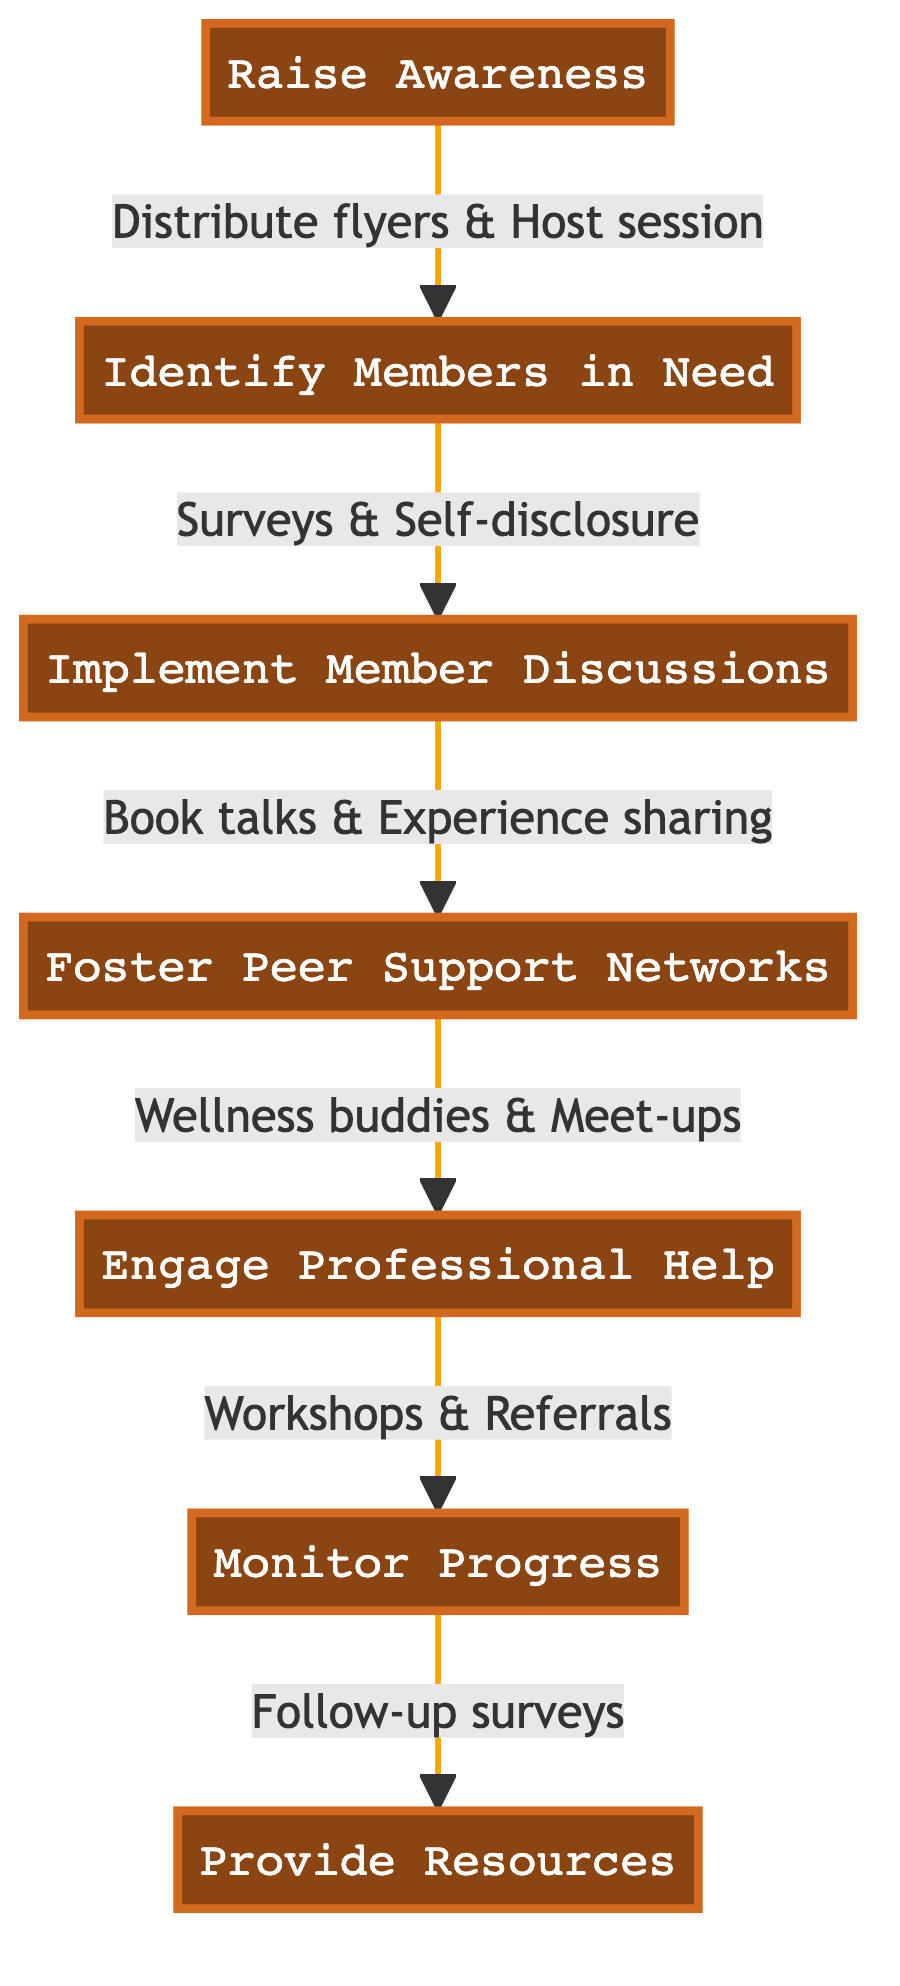What is the first step in the clinical pathway? The diagram indicates that the first step is "Raise Awareness," which initiates the clinical pathway for mental health support in book clubs.
Answer: Raise Awareness How many main steps are in the clinical pathway? By counting the nodes in the diagram, there are a total of seven main steps, which include Raise Awareness, Identify Members in Need, Implement Member Discussions, Foster Peer Support Networks, Engage Professional Help, Monitor Progress, and Provide Resources.
Answer: Seven What action is associated with "Identify Members in Need"? The action associated with "Identify Members in Need" is to conduct anonymous mental health surveys within the book club and encourage self-disclosure in a safe space.
Answer: Conduct anonymous mental health surveys Which step directly follows "Engage Professional Help"? The step that follows "Engage Professional Help" is "Monitor Progress," indicating the next phase of intervention after professional engagement.
Answer: Monitor Progress What type of support is suggested in the "Foster Peer Support Networks"? The suggested support in "Foster Peer Support Networks" includes pairing members as 'wellness buddies' and organizing meet-ups for mental wellbeing activities, which enhances peer support within the club.
Answer: Wellness buddies What is the purpose of the "Provide Resources" step? The purpose of the "Provide Resources" step is to curate a list of mental health books and disseminate information on emergency helplines and support groups, facilitating better access to mental health resources for club members.
Answer: Provide a list of mental health books What actions are suggested to raise awareness? The actions suggested to raise awareness include distributing flyers about mental health awareness and hosting an introductory session on mental health with a focus on bibliotherapy.
Answer: Distribute flyers & Host session How do the steps relate to one another in the context of support mechanisms? The steps are sequential, starting from raising awareness, leading to identifying member needs, implementing discussions, fostering peer support, engaging professionals, monitoring progress, and providing resources, indicating a comprehensive pathway to mental health support.
Answer: Sequential progression What kind of professionals should be invited as per the "Engage Professional Help" step? The diagram suggests inviting local mental health professionals for workshops or group therapy sessions to provide professional intervention and support for book club members.
Answer: Local mental health professionals 